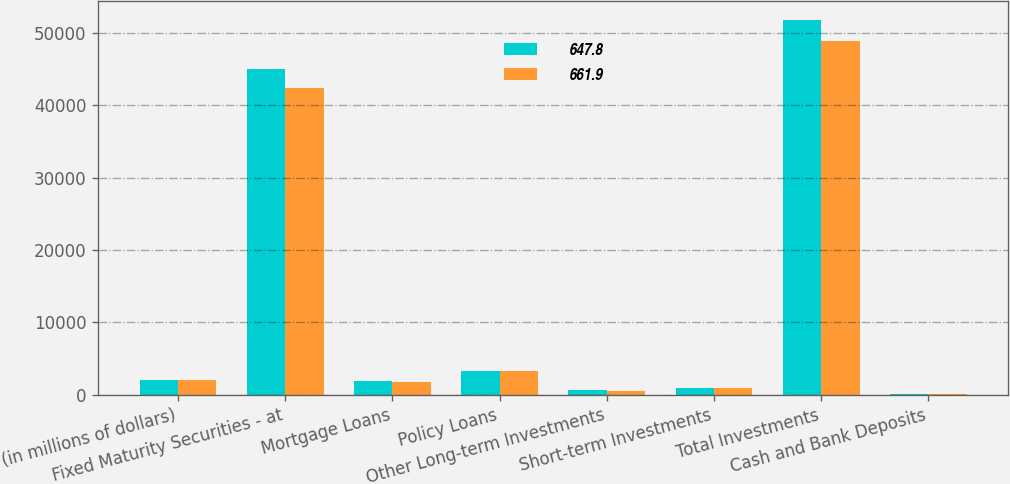<chart> <loc_0><loc_0><loc_500><loc_500><stacked_bar_chart><ecel><fcel>(in millions of dollars)<fcel>Fixed Maturity Securities - at<fcel>Mortgage Loans<fcel>Policy Loans<fcel>Other Long-term Investments<fcel>Short-term Investments<fcel>Total Investments<fcel>Cash and Bank Deposits<nl><fcel>647.8<fcel>2014<fcel>45064.9<fcel>1856.6<fcel>3306.6<fcel>591.9<fcel>974.3<fcel>51794.3<fcel>102.5<nl><fcel>661.9<fcel>2013<fcel>42344.4<fcel>1815.1<fcel>3276<fcel>566<fcel>913.4<fcel>48914.9<fcel>94.1<nl></chart> 